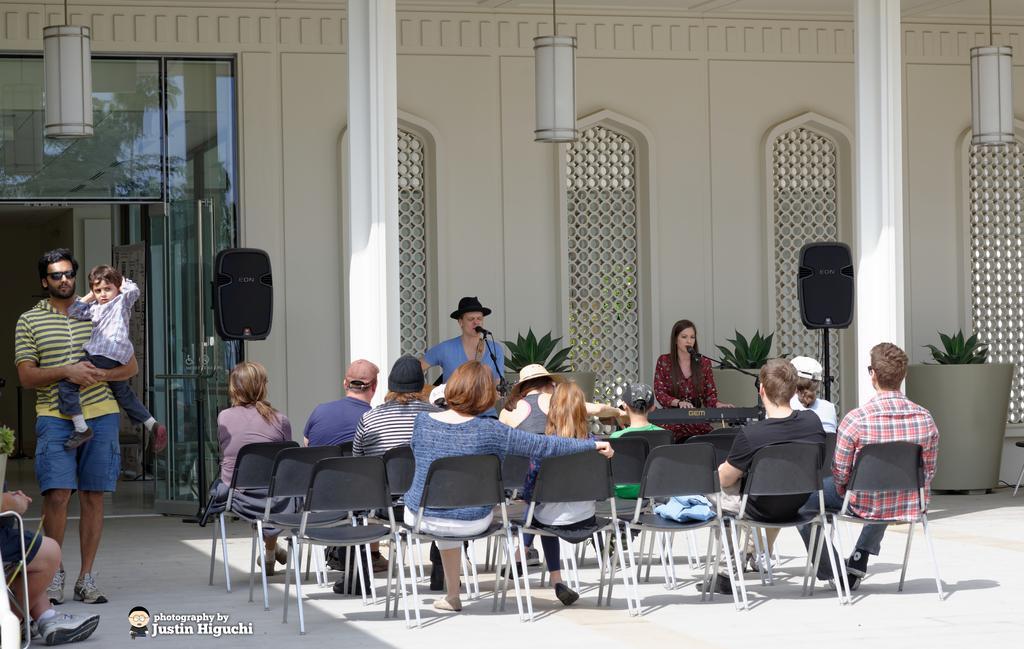In one or two sentences, can you explain what this image depicts? In this picture we can see a group of people where here man and woman are singing on mic playing musical instrument such as piano and here we can see man walking in background we can see speaker, wall, lamp, flower pot with plant. 